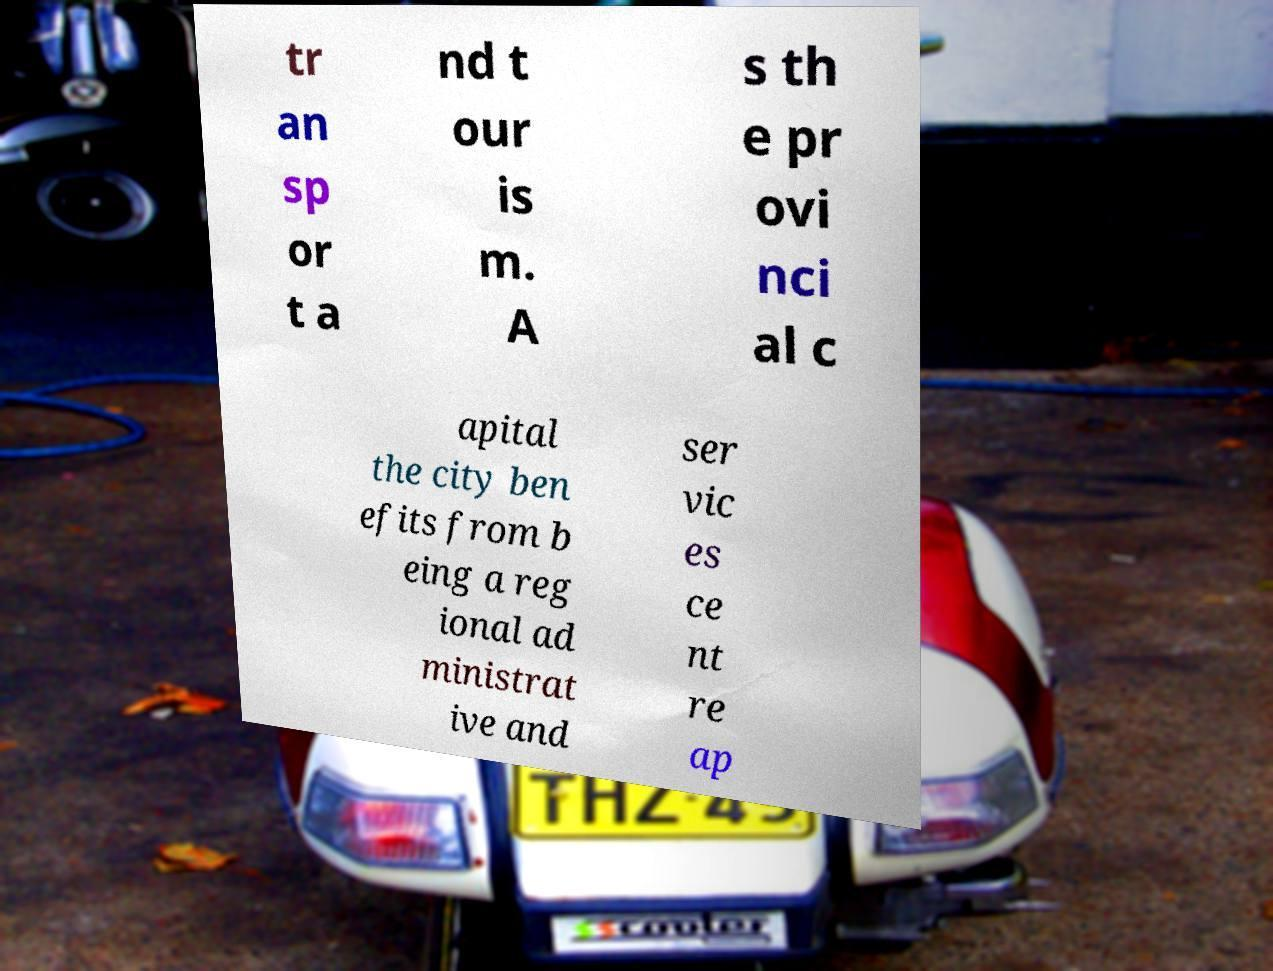Please read and relay the text visible in this image. What does it say? tr an sp or t a nd t our is m. A s th e pr ovi nci al c apital the city ben efits from b eing a reg ional ad ministrat ive and ser vic es ce nt re ap 